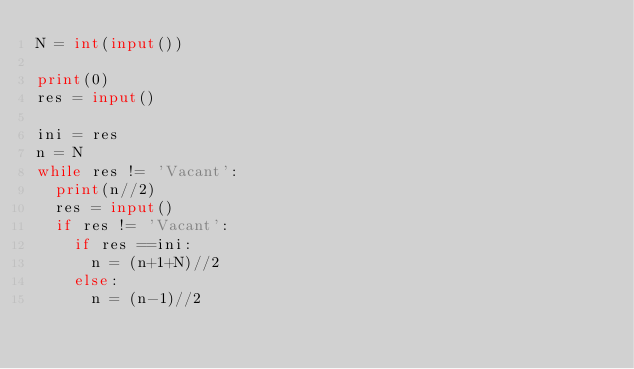<code> <loc_0><loc_0><loc_500><loc_500><_Python_>N = int(input())

print(0)
res = input()

ini = res
n = N
while res != 'Vacant':
  print(n//2)
  res = input()
  if res != 'Vacant':
    if res ==ini:
      n = (n+1+N)//2
    else:
      n = (n-1)//2</code> 